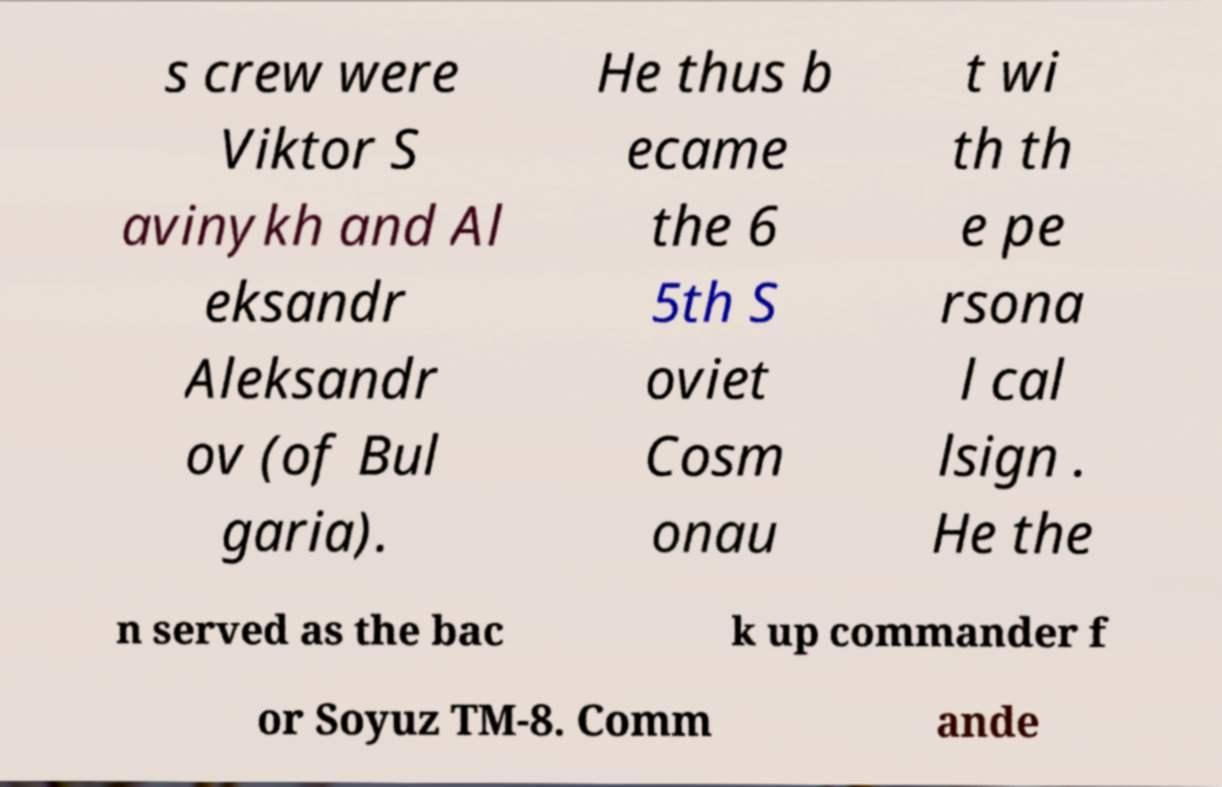There's text embedded in this image that I need extracted. Can you transcribe it verbatim? s crew were Viktor S avinykh and Al eksandr Aleksandr ov (of Bul garia). He thus b ecame the 6 5th S oviet Cosm onau t wi th th e pe rsona l cal lsign . He the n served as the bac k up commander f or Soyuz TM-8. Comm ande 